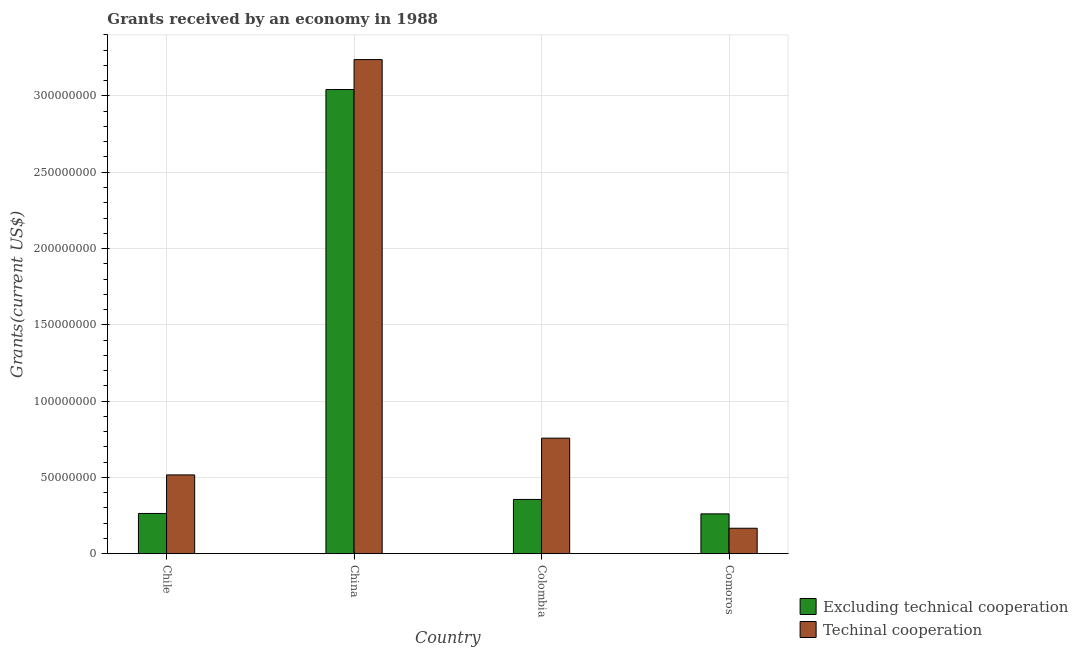Are the number of bars on each tick of the X-axis equal?
Your answer should be very brief. Yes. What is the amount of grants received(excluding technical cooperation) in Colombia?
Your response must be concise. 3.56e+07. Across all countries, what is the maximum amount of grants received(including technical cooperation)?
Keep it short and to the point. 3.24e+08. Across all countries, what is the minimum amount of grants received(excluding technical cooperation)?
Offer a very short reply. 2.61e+07. In which country was the amount of grants received(including technical cooperation) minimum?
Your answer should be compact. Comoros. What is the total amount of grants received(including technical cooperation) in the graph?
Provide a short and direct response. 4.68e+08. What is the difference between the amount of grants received(including technical cooperation) in China and that in Comoros?
Your answer should be very brief. 3.07e+08. What is the difference between the amount of grants received(excluding technical cooperation) in Comoros and the amount of grants received(including technical cooperation) in Chile?
Your response must be concise. -2.55e+07. What is the average amount of grants received(excluding technical cooperation) per country?
Provide a succinct answer. 9.81e+07. What is the difference between the amount of grants received(including technical cooperation) and amount of grants received(excluding technical cooperation) in China?
Offer a terse response. 1.96e+07. In how many countries, is the amount of grants received(excluding technical cooperation) greater than 170000000 US$?
Make the answer very short. 1. What is the ratio of the amount of grants received(including technical cooperation) in Chile to that in Colombia?
Provide a short and direct response. 0.68. What is the difference between the highest and the second highest amount of grants received(including technical cooperation)?
Give a very brief answer. 2.48e+08. What is the difference between the highest and the lowest amount of grants received(excluding technical cooperation)?
Your answer should be very brief. 2.78e+08. In how many countries, is the amount of grants received(including technical cooperation) greater than the average amount of grants received(including technical cooperation) taken over all countries?
Keep it short and to the point. 1. What does the 2nd bar from the left in Comoros represents?
Your answer should be very brief. Techinal cooperation. What does the 2nd bar from the right in Comoros represents?
Provide a succinct answer. Excluding technical cooperation. How many bars are there?
Your answer should be compact. 8. Are all the bars in the graph horizontal?
Keep it short and to the point. No. How many countries are there in the graph?
Provide a short and direct response. 4. What is the difference between two consecutive major ticks on the Y-axis?
Keep it short and to the point. 5.00e+07. Where does the legend appear in the graph?
Provide a short and direct response. Bottom right. What is the title of the graph?
Your response must be concise. Grants received by an economy in 1988. Does "Registered firms" appear as one of the legend labels in the graph?
Offer a very short reply. No. What is the label or title of the Y-axis?
Give a very brief answer. Grants(current US$). What is the Grants(current US$) of Excluding technical cooperation in Chile?
Your answer should be compact. 2.64e+07. What is the Grants(current US$) of Techinal cooperation in Chile?
Provide a short and direct response. 5.16e+07. What is the Grants(current US$) in Excluding technical cooperation in China?
Your answer should be compact. 3.04e+08. What is the Grants(current US$) of Techinal cooperation in China?
Offer a terse response. 3.24e+08. What is the Grants(current US$) in Excluding technical cooperation in Colombia?
Offer a very short reply. 3.56e+07. What is the Grants(current US$) in Techinal cooperation in Colombia?
Give a very brief answer. 7.57e+07. What is the Grants(current US$) in Excluding technical cooperation in Comoros?
Offer a very short reply. 2.61e+07. What is the Grants(current US$) in Techinal cooperation in Comoros?
Provide a short and direct response. 1.67e+07. Across all countries, what is the maximum Grants(current US$) of Excluding technical cooperation?
Keep it short and to the point. 3.04e+08. Across all countries, what is the maximum Grants(current US$) in Techinal cooperation?
Ensure brevity in your answer.  3.24e+08. Across all countries, what is the minimum Grants(current US$) in Excluding technical cooperation?
Offer a very short reply. 2.61e+07. Across all countries, what is the minimum Grants(current US$) in Techinal cooperation?
Give a very brief answer. 1.67e+07. What is the total Grants(current US$) in Excluding technical cooperation in the graph?
Keep it short and to the point. 3.92e+08. What is the total Grants(current US$) of Techinal cooperation in the graph?
Your answer should be compact. 4.68e+08. What is the difference between the Grants(current US$) in Excluding technical cooperation in Chile and that in China?
Make the answer very short. -2.78e+08. What is the difference between the Grants(current US$) in Techinal cooperation in Chile and that in China?
Offer a very short reply. -2.72e+08. What is the difference between the Grants(current US$) in Excluding technical cooperation in Chile and that in Colombia?
Your answer should be very brief. -9.19e+06. What is the difference between the Grants(current US$) of Techinal cooperation in Chile and that in Colombia?
Ensure brevity in your answer.  -2.41e+07. What is the difference between the Grants(current US$) of Techinal cooperation in Chile and that in Comoros?
Provide a succinct answer. 3.50e+07. What is the difference between the Grants(current US$) of Excluding technical cooperation in China and that in Colombia?
Give a very brief answer. 2.69e+08. What is the difference between the Grants(current US$) in Techinal cooperation in China and that in Colombia?
Keep it short and to the point. 2.48e+08. What is the difference between the Grants(current US$) of Excluding technical cooperation in China and that in Comoros?
Give a very brief answer. 2.78e+08. What is the difference between the Grants(current US$) of Techinal cooperation in China and that in Comoros?
Your answer should be very brief. 3.07e+08. What is the difference between the Grants(current US$) of Excluding technical cooperation in Colombia and that in Comoros?
Offer a terse response. 9.46e+06. What is the difference between the Grants(current US$) in Techinal cooperation in Colombia and that in Comoros?
Give a very brief answer. 5.90e+07. What is the difference between the Grants(current US$) of Excluding technical cooperation in Chile and the Grants(current US$) of Techinal cooperation in China?
Your response must be concise. -2.97e+08. What is the difference between the Grants(current US$) of Excluding technical cooperation in Chile and the Grants(current US$) of Techinal cooperation in Colombia?
Give a very brief answer. -4.93e+07. What is the difference between the Grants(current US$) in Excluding technical cooperation in Chile and the Grants(current US$) in Techinal cooperation in Comoros?
Provide a succinct answer. 9.69e+06. What is the difference between the Grants(current US$) of Excluding technical cooperation in China and the Grants(current US$) of Techinal cooperation in Colombia?
Keep it short and to the point. 2.28e+08. What is the difference between the Grants(current US$) of Excluding technical cooperation in China and the Grants(current US$) of Techinal cooperation in Comoros?
Give a very brief answer. 2.88e+08. What is the difference between the Grants(current US$) in Excluding technical cooperation in Colombia and the Grants(current US$) in Techinal cooperation in Comoros?
Your response must be concise. 1.89e+07. What is the average Grants(current US$) in Excluding technical cooperation per country?
Offer a terse response. 9.81e+07. What is the average Grants(current US$) in Techinal cooperation per country?
Give a very brief answer. 1.17e+08. What is the difference between the Grants(current US$) in Excluding technical cooperation and Grants(current US$) in Techinal cooperation in Chile?
Your response must be concise. -2.53e+07. What is the difference between the Grants(current US$) of Excluding technical cooperation and Grants(current US$) of Techinal cooperation in China?
Offer a terse response. -1.96e+07. What is the difference between the Grants(current US$) in Excluding technical cooperation and Grants(current US$) in Techinal cooperation in Colombia?
Your answer should be compact. -4.02e+07. What is the difference between the Grants(current US$) of Excluding technical cooperation and Grants(current US$) of Techinal cooperation in Comoros?
Your answer should be compact. 9.42e+06. What is the ratio of the Grants(current US$) in Excluding technical cooperation in Chile to that in China?
Your answer should be compact. 0.09. What is the ratio of the Grants(current US$) in Techinal cooperation in Chile to that in China?
Provide a short and direct response. 0.16. What is the ratio of the Grants(current US$) of Excluding technical cooperation in Chile to that in Colombia?
Give a very brief answer. 0.74. What is the ratio of the Grants(current US$) of Techinal cooperation in Chile to that in Colombia?
Ensure brevity in your answer.  0.68. What is the ratio of the Grants(current US$) of Excluding technical cooperation in Chile to that in Comoros?
Provide a short and direct response. 1.01. What is the ratio of the Grants(current US$) in Techinal cooperation in Chile to that in Comoros?
Provide a succinct answer. 3.09. What is the ratio of the Grants(current US$) of Excluding technical cooperation in China to that in Colombia?
Your answer should be compact. 8.55. What is the ratio of the Grants(current US$) in Techinal cooperation in China to that in Colombia?
Your answer should be compact. 4.28. What is the ratio of the Grants(current US$) of Excluding technical cooperation in China to that in Comoros?
Give a very brief answer. 11.65. What is the ratio of the Grants(current US$) in Techinal cooperation in China to that in Comoros?
Give a very brief answer. 19.39. What is the ratio of the Grants(current US$) in Excluding technical cooperation in Colombia to that in Comoros?
Your answer should be very brief. 1.36. What is the ratio of the Grants(current US$) of Techinal cooperation in Colombia to that in Comoros?
Offer a very short reply. 4.53. What is the difference between the highest and the second highest Grants(current US$) in Excluding technical cooperation?
Offer a very short reply. 2.69e+08. What is the difference between the highest and the second highest Grants(current US$) in Techinal cooperation?
Ensure brevity in your answer.  2.48e+08. What is the difference between the highest and the lowest Grants(current US$) in Excluding technical cooperation?
Your response must be concise. 2.78e+08. What is the difference between the highest and the lowest Grants(current US$) in Techinal cooperation?
Provide a succinct answer. 3.07e+08. 